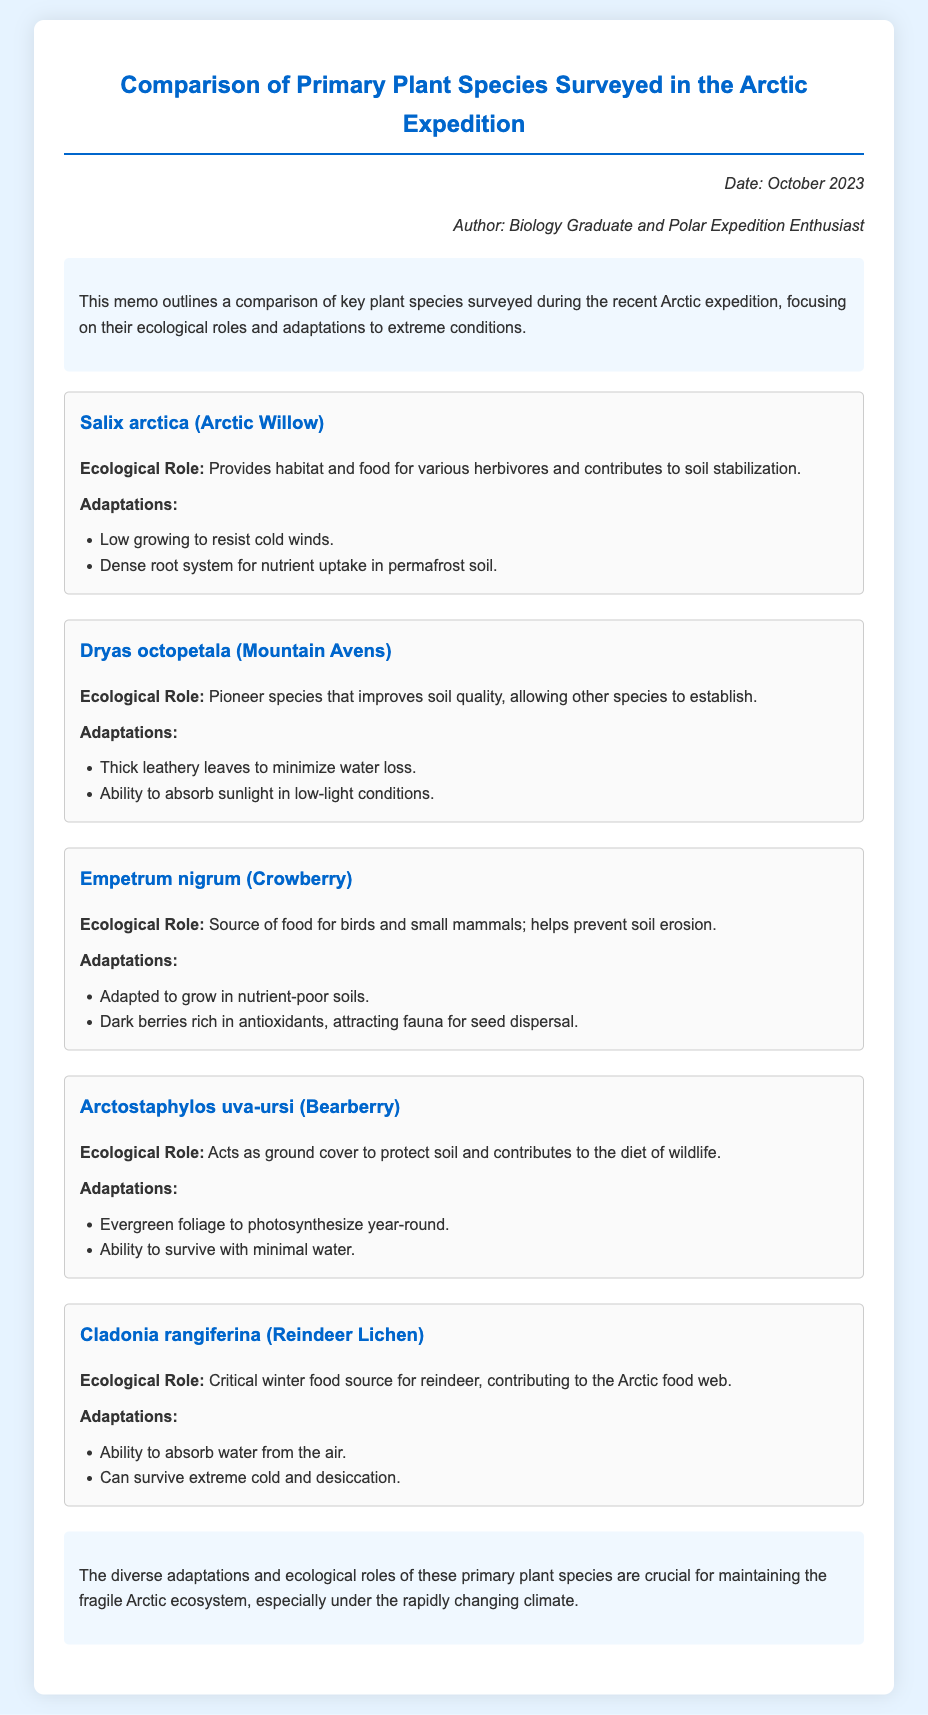what is the title of the document? The title is stated at the beginning of the memo, specifying the content it covers.
Answer: Comparison of Primary Plant Species Surveyed in the Arctic Expedition who is the author of the memo? The author is mentioned in the header section of the document.
Answer: Biology Graduate and Polar Expedition Enthusiast what is the ecological role of Salix arctica? This information is provided in the section discussing its ecological contributions.
Answer: Provides habitat and food for various herbivores and contributes to soil stabilization how many species are surveyed in the document? The total number of species can be counted from the sections dedicated to each plant.
Answer: Five which species is adapted to grow in nutrient-poor soils? Adaptations are listed for each species, indicating which one fits this description.
Answer: Empetrum nigrum what are the adaptations of Cladonia rangiferina? The adaptations section provides specific traits for this species.
Answer: Ability to absorb water from the air; can survive extreme cold and desiccation what is the date of the memo? The date is noted in the meta section of the document for context.
Answer: October 2023 which plant species is considered a pioneer species? This is noted in the section highlighting the roles of various species.
Answer: Dryas octopetala 